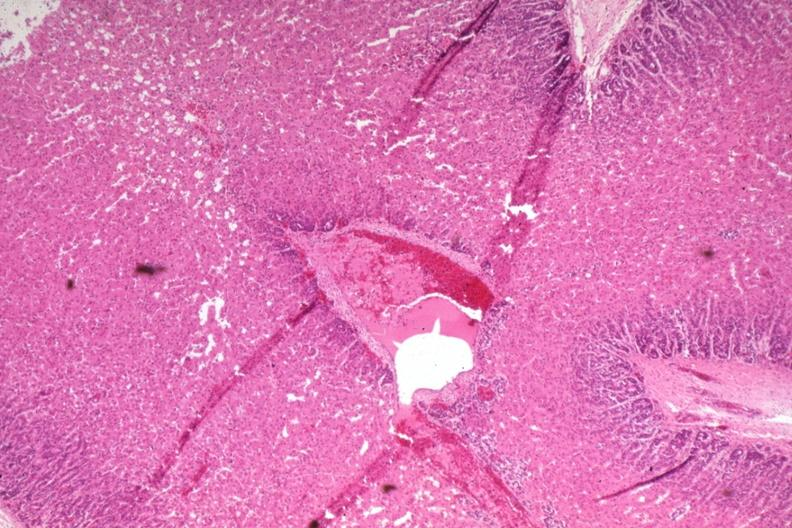s normal newborn present?
Answer the question using a single word or phrase. Yes 